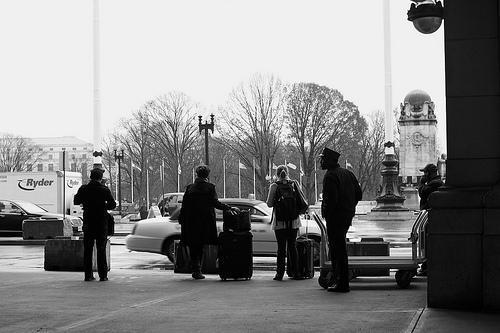How many people are shown?
Give a very brief answer. 5. How many vehicles are shown?
Give a very brief answer. 4. 